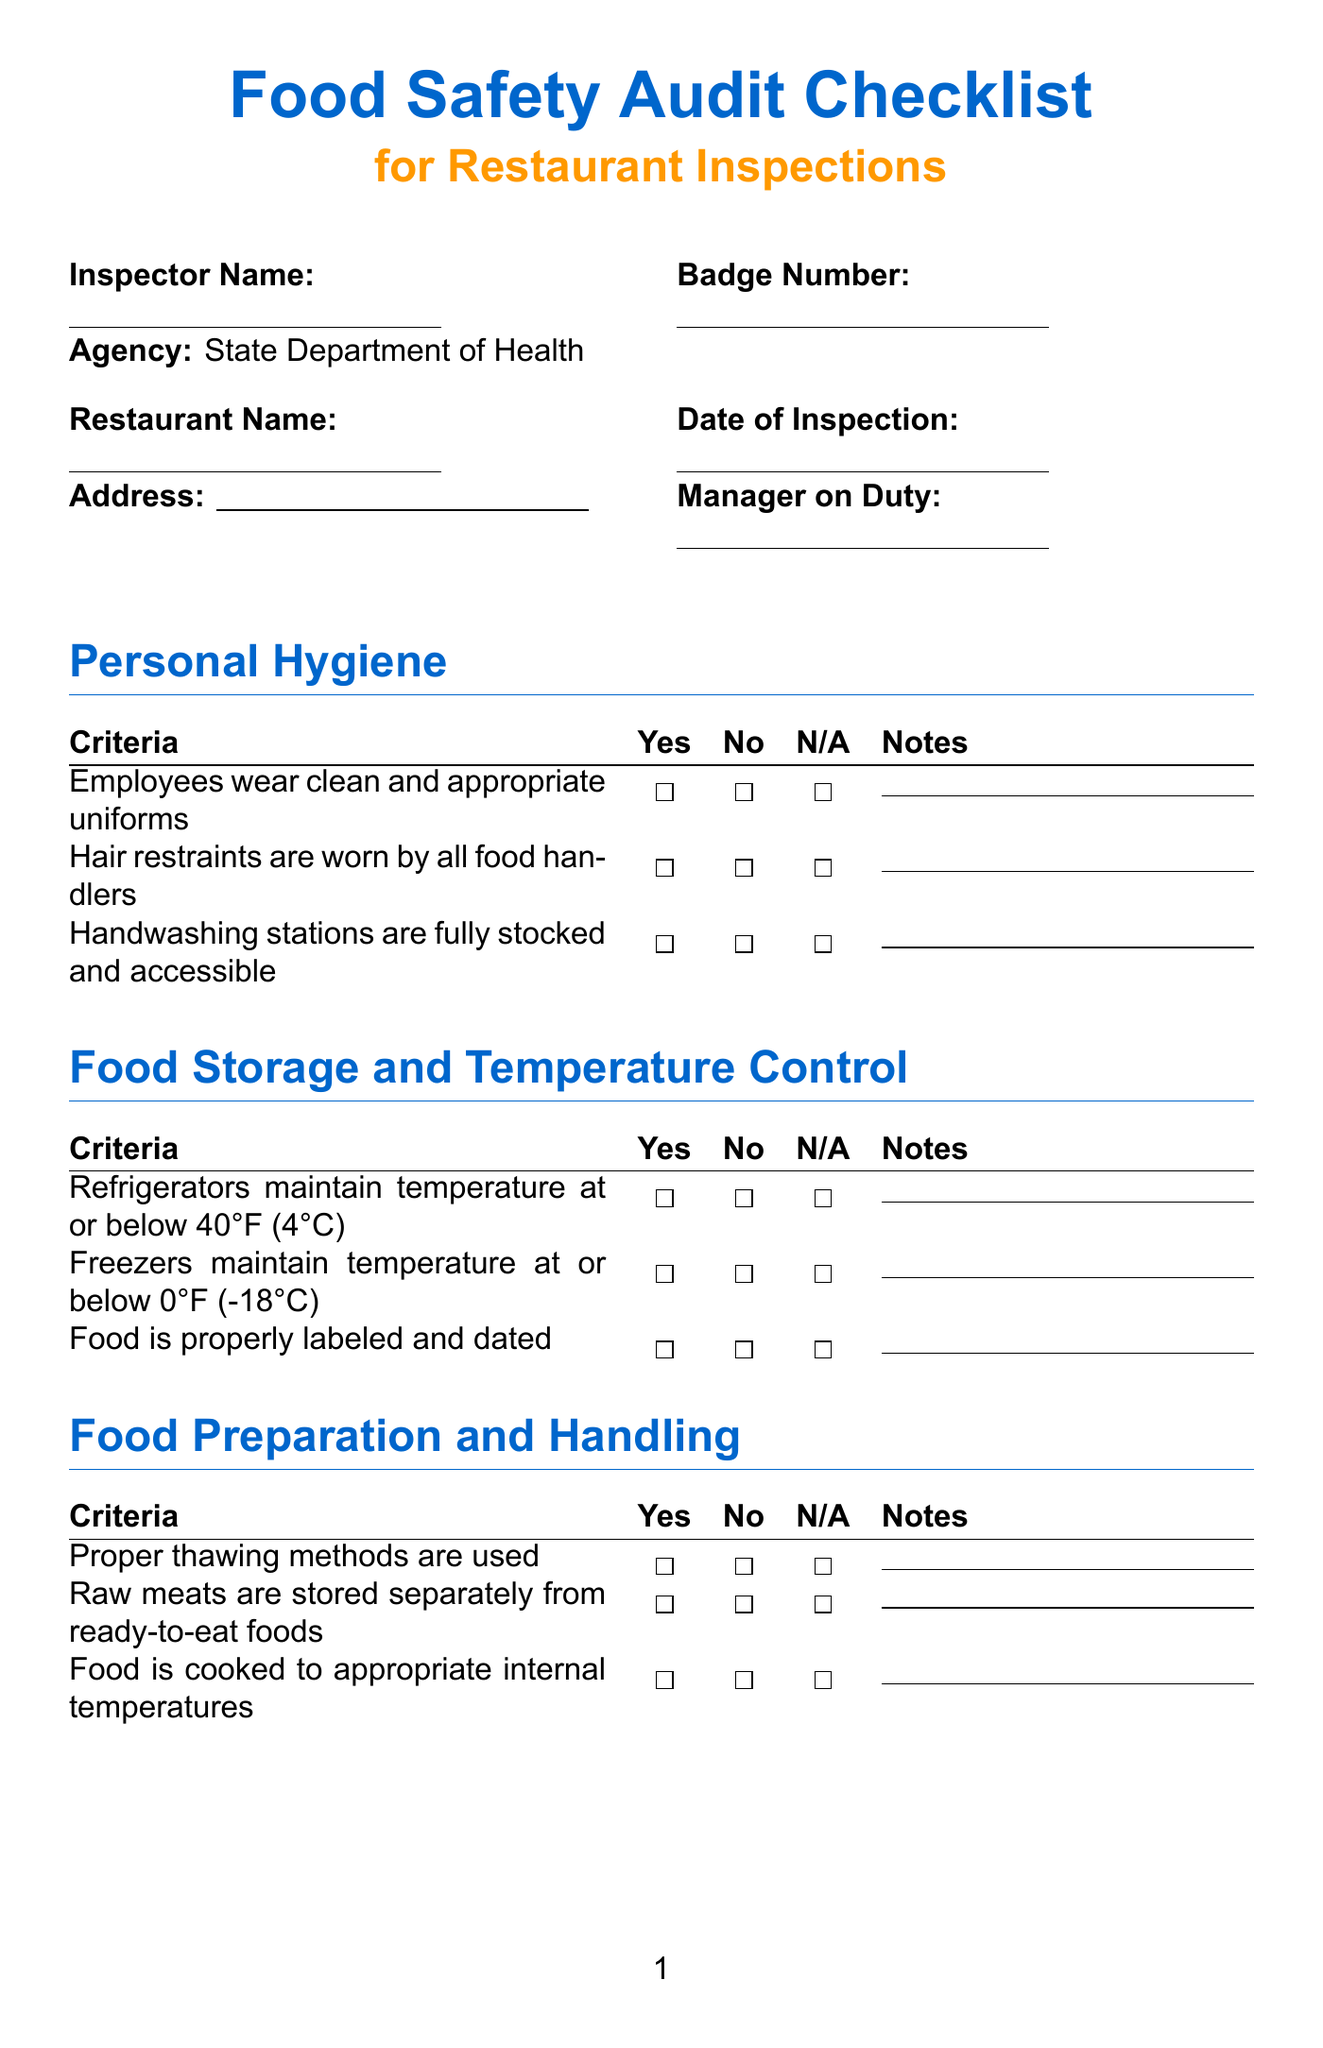What is the title of the document? The title of the document is specified at the beginning and provides the main focus of the checklist.
Answer: Food Safety Audit Checklist for Restaurant Inspections What is the agency associated with the inspector? The agency details are provided within the inspector information section, representing the performing authority.
Answer: State Department of Health How many items are listed under Personal Hygiene? The checklist indicates the number of criteria listed in the Personal Hygiene section to assess compliance.
Answer: 3 What does the criteria for food storage say about freezers? The criteria for food storage specifies the required temperature for freezers to be compliant during the inspection.
Answer: Freezers maintain temperature at or below 0°F (-18°C) What is indicated about pest control measures? Pest control measures are critical in the checklist, covering both evidence of infestation and measures in place.
Answer: Pest control measures are in place and documented Is a follow-up required? The follow-up requirement informs whether additional actions or inspections are necessary based on findings.
Answer: Yes / No (to be specified) 